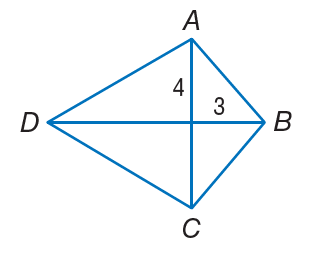Answer the mathemtical geometry problem and directly provide the correct option letter.
Question: If A B C D is a kite, find A B.
Choices: A: 3 B: 4 C: 5 D: 7 C 